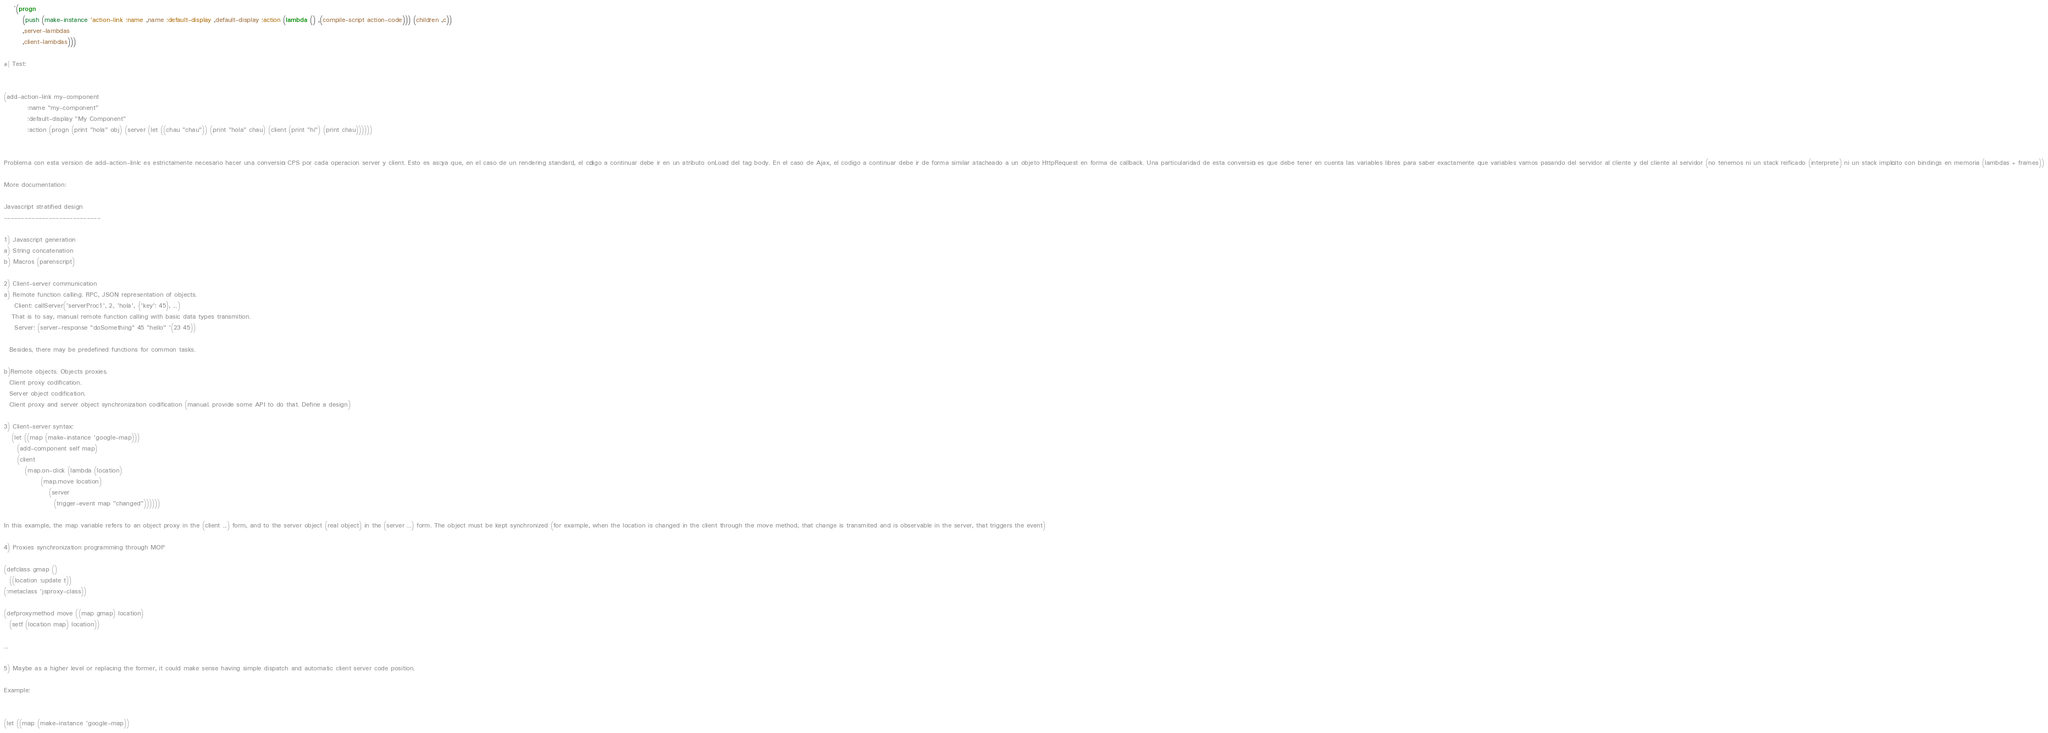<code> <loc_0><loc_0><loc_500><loc_500><_Lisp_>    `(progn
       (push (make-instance 'action-link :name ,name :default-display ,default-display :action (lambda () ,(compile-script action-code))) (children ,c))
       ,server-lambdas
       ,client-lambdas)))

#| Test:


(add-action-link my-component
		 :name "my-component"
		 :default-display "My Component"
		 :action (progn (print "hola" obj) (server (let ((chau "chau")) (print "hola" chau) (client (print "hi") (print chau))))))


Problema con esta version de add-action-link: es estrictamente necesario hacer una conversión CPS por cada operacion server y client. Esto es así ya que, en el caso de un rendering standard, el código a continuar debe ir en un atributo onLoad del tag body. En el caso de Ajax, el codigo a continuar debe ir de forma similar atacheado a un objeto HttpRequest en forma de callback. Una particularidad de esta conversión es que debe tener en cuenta las variables libres para saber exactamente que variables vamos pasando del servidor al cliente y del cliente al servidor (no tenemos ni un stack reificado (interprete) ni un stack implícito con bindings en memoria (lambdas + frames))

More documentation:

Javascript stratified design
----------------------------

1) Javascript generation
a) String concatenation
b) Macros (parenscript)

2) Client-server communication
a) Remote function calling. RPC, JSON representation of objects.
    Client: callServer('serverProc1', 2, 'hola', {'key': 45}, ...)
   That is to say, manual remote function calling with basic data types transmition.
    Server: (server-response "doSomething" 45 "hello" '(23 45))

  Besides, there may be predefined functions for common tasks.

b)Remote objects. Objects proxies.
  Client proxy codification.
  Server object codification.
  Client proxy and server object synchronization codification (manual. provide some API to do that. Define a design)

3) Client-server syntax:
   (let ((map (make-instance 'google-map)))
     (add-component self map)
     (client
        (map.on-click (lambda (location)
              (map.move location)
                 (server
                   (trigger-event map "changed"))))))

In this example, the map variable refers to an object proxy in the (client ...) form, and to the server object (real object) in the (server ...) form. The object must be kept synchronized (for example, when the location is changed in the client through the move method, that change is transmited and is observable in the server, that triggers the event)

4) Proxies synchronization programming through MOP

(defclass gmap ()
  ((location :update t))
(:metaclass 'jsproxy-class))

(defproxymethod move ((map gmap) location)
  (setf (location map) location))

...

5) Maybe as a higher level or replacing the former, it could make sense having simple dispatch and automatic client server code position.

Example:


(let ((map (make-instance 'google-map))</code> 